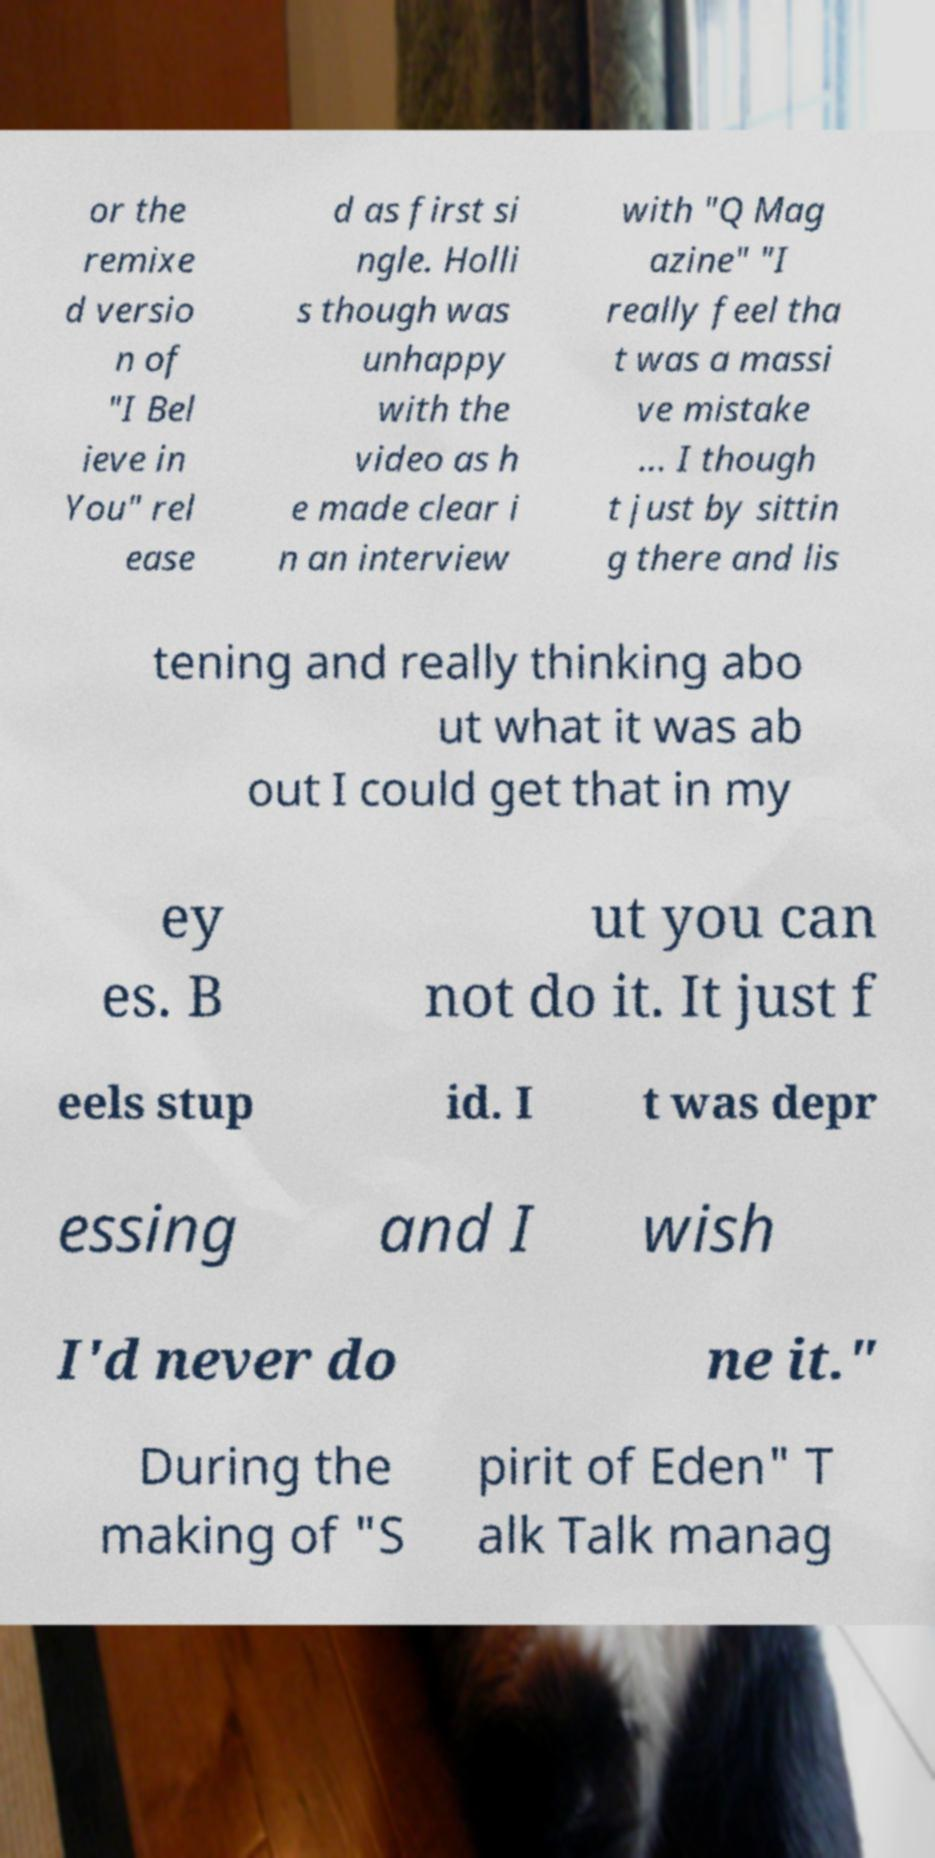Please identify and transcribe the text found in this image. or the remixe d versio n of "I Bel ieve in You" rel ease d as first si ngle. Holli s though was unhappy with the video as h e made clear i n an interview with "Q Mag azine" "I really feel tha t was a massi ve mistake ... I though t just by sittin g there and lis tening and really thinking abo ut what it was ab out I could get that in my ey es. B ut you can not do it. It just f eels stup id. I t was depr essing and I wish I'd never do ne it." During the making of "S pirit of Eden" T alk Talk manag 